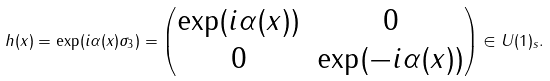<formula> <loc_0><loc_0><loc_500><loc_500>h ( x ) = \exp ( i \alpha ( x ) \sigma _ { 3 } ) = \begin{pmatrix} \exp ( i \alpha ( x ) ) & 0 \\ 0 & \exp ( - i \alpha ( x ) ) \end{pmatrix} \in U ( 1 ) _ { s } .</formula> 